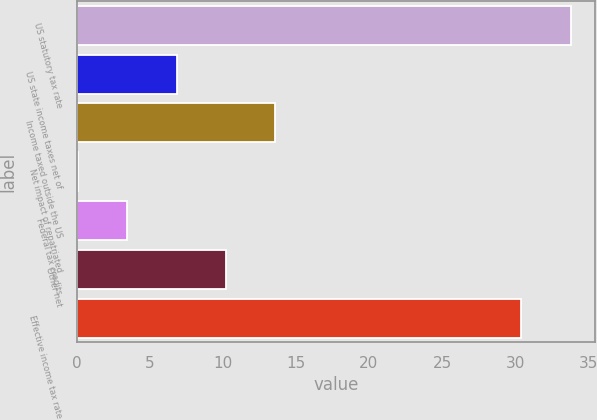<chart> <loc_0><loc_0><loc_500><loc_500><bar_chart><fcel>US statutory tax rate<fcel>US state income taxes net of<fcel>Income taxed outside the US<fcel>Net impact of repatriated<fcel>Federal tax credits<fcel>Other net<fcel>Effective income tax rate<nl><fcel>33.8<fcel>6.84<fcel>13.58<fcel>0.1<fcel>3.47<fcel>10.21<fcel>30.4<nl></chart> 